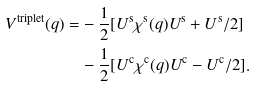Convert formula to latex. <formula><loc_0><loc_0><loc_500><loc_500>V ^ { \text {triplet} } ( q ) = & - \frac { 1 } { 2 } [ U ^ { \text {s} } \chi ^ { \text {s} } ( q ) U ^ { \text {s} } + U ^ { \text {s} } / 2 ] \\ & - \frac { 1 } { 2 } [ U ^ { \text {c} } \chi ^ { \text {c} } ( q ) U ^ { \text {c} } - U ^ { \text {c} } / 2 ] .</formula> 